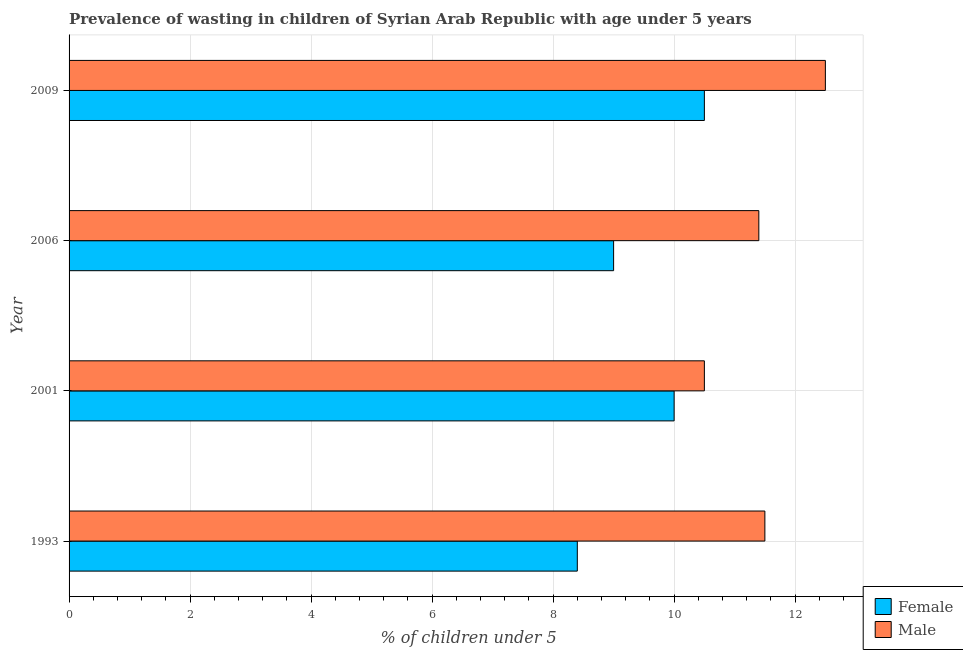How many groups of bars are there?
Keep it short and to the point. 4. Are the number of bars per tick equal to the number of legend labels?
Keep it short and to the point. Yes. Are the number of bars on each tick of the Y-axis equal?
Your answer should be compact. Yes. How many bars are there on the 1st tick from the top?
Ensure brevity in your answer.  2. How many bars are there on the 1st tick from the bottom?
Your answer should be very brief. 2. In how many cases, is the number of bars for a given year not equal to the number of legend labels?
Your response must be concise. 0. What is the percentage of undernourished male children in 2006?
Your response must be concise. 11.4. Across all years, what is the maximum percentage of undernourished female children?
Keep it short and to the point. 10.5. Across all years, what is the minimum percentage of undernourished female children?
Keep it short and to the point. 8.4. In which year was the percentage of undernourished male children maximum?
Your response must be concise. 2009. In which year was the percentage of undernourished male children minimum?
Your response must be concise. 2001. What is the total percentage of undernourished female children in the graph?
Provide a short and direct response. 37.9. What is the average percentage of undernourished female children per year?
Make the answer very short. 9.47. In how many years, is the percentage of undernourished male children greater than 8 %?
Keep it short and to the point. 4. What is the ratio of the percentage of undernourished female children in 2001 to that in 2006?
Keep it short and to the point. 1.11. Is the percentage of undernourished male children in 1993 less than that in 2006?
Make the answer very short. No. Is the difference between the percentage of undernourished male children in 2001 and 2006 greater than the difference between the percentage of undernourished female children in 2001 and 2006?
Your response must be concise. No. What is the difference between the highest and the second highest percentage of undernourished female children?
Provide a short and direct response. 0.5. Is the sum of the percentage of undernourished female children in 1993 and 2001 greater than the maximum percentage of undernourished male children across all years?
Your answer should be very brief. Yes. Are all the bars in the graph horizontal?
Give a very brief answer. Yes. What is the difference between two consecutive major ticks on the X-axis?
Ensure brevity in your answer.  2. Are the values on the major ticks of X-axis written in scientific E-notation?
Offer a terse response. No. How many legend labels are there?
Provide a succinct answer. 2. How are the legend labels stacked?
Keep it short and to the point. Vertical. What is the title of the graph?
Give a very brief answer. Prevalence of wasting in children of Syrian Arab Republic with age under 5 years. What is the label or title of the X-axis?
Your response must be concise.  % of children under 5. What is the  % of children under 5 of Female in 1993?
Provide a short and direct response. 8.4. What is the  % of children under 5 of Female in 2001?
Ensure brevity in your answer.  10. What is the  % of children under 5 in Male in 2001?
Your answer should be compact. 10.5. What is the  % of children under 5 of Female in 2006?
Give a very brief answer. 9. What is the  % of children under 5 of Male in 2006?
Ensure brevity in your answer.  11.4. What is the  % of children under 5 in Male in 2009?
Your answer should be very brief. 12.5. Across all years, what is the maximum  % of children under 5 in Male?
Ensure brevity in your answer.  12.5. Across all years, what is the minimum  % of children under 5 in Female?
Provide a short and direct response. 8.4. Across all years, what is the minimum  % of children under 5 of Male?
Make the answer very short. 10.5. What is the total  % of children under 5 of Female in the graph?
Keep it short and to the point. 37.9. What is the total  % of children under 5 of Male in the graph?
Give a very brief answer. 45.9. What is the difference between the  % of children under 5 of Male in 1993 and that in 2001?
Offer a terse response. 1. What is the difference between the  % of children under 5 in Male in 1993 and that in 2009?
Keep it short and to the point. -1. What is the difference between the  % of children under 5 in Female in 2001 and that in 2009?
Provide a succinct answer. -0.5. What is the difference between the  % of children under 5 of Male in 2001 and that in 2009?
Give a very brief answer. -2. What is the difference between the  % of children under 5 in Male in 2006 and that in 2009?
Your response must be concise. -1.1. What is the difference between the  % of children under 5 in Female in 1993 and the  % of children under 5 in Male in 2001?
Keep it short and to the point. -2.1. What is the difference between the  % of children under 5 of Female in 1993 and the  % of children under 5 of Male in 2006?
Your answer should be very brief. -3. What is the average  % of children under 5 in Female per year?
Make the answer very short. 9.47. What is the average  % of children under 5 of Male per year?
Provide a short and direct response. 11.47. In the year 2009, what is the difference between the  % of children under 5 in Female and  % of children under 5 in Male?
Offer a very short reply. -2. What is the ratio of the  % of children under 5 of Female in 1993 to that in 2001?
Provide a succinct answer. 0.84. What is the ratio of the  % of children under 5 of Male in 1993 to that in 2001?
Ensure brevity in your answer.  1.1. What is the ratio of the  % of children under 5 in Male in 1993 to that in 2006?
Provide a short and direct response. 1.01. What is the ratio of the  % of children under 5 of Female in 2001 to that in 2006?
Make the answer very short. 1.11. What is the ratio of the  % of children under 5 in Male in 2001 to that in 2006?
Your answer should be very brief. 0.92. What is the ratio of the  % of children under 5 in Female in 2001 to that in 2009?
Give a very brief answer. 0.95. What is the ratio of the  % of children under 5 in Male in 2001 to that in 2009?
Provide a short and direct response. 0.84. What is the ratio of the  % of children under 5 of Female in 2006 to that in 2009?
Give a very brief answer. 0.86. What is the ratio of the  % of children under 5 of Male in 2006 to that in 2009?
Your answer should be very brief. 0.91. What is the difference between the highest and the second highest  % of children under 5 in Female?
Make the answer very short. 0.5. What is the difference between the highest and the second highest  % of children under 5 of Male?
Give a very brief answer. 1. 